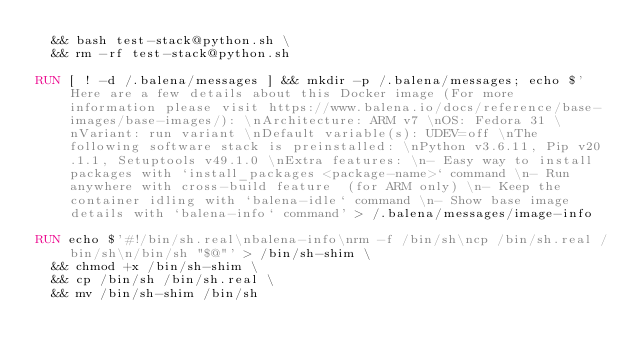<code> <loc_0><loc_0><loc_500><loc_500><_Dockerfile_>  && bash test-stack@python.sh \
  && rm -rf test-stack@python.sh 

RUN [ ! -d /.balena/messages ] && mkdir -p /.balena/messages; echo $'Here are a few details about this Docker image (For more information please visit https://www.balena.io/docs/reference/base-images/base-images/): \nArchitecture: ARM v7 \nOS: Fedora 31 \nVariant: run variant \nDefault variable(s): UDEV=off \nThe following software stack is preinstalled: \nPython v3.6.11, Pip v20.1.1, Setuptools v49.1.0 \nExtra features: \n- Easy way to install packages with `install_packages <package-name>` command \n- Run anywhere with cross-build feature  (for ARM only) \n- Keep the container idling with `balena-idle` command \n- Show base image details with `balena-info` command' > /.balena/messages/image-info

RUN echo $'#!/bin/sh.real\nbalena-info\nrm -f /bin/sh\ncp /bin/sh.real /bin/sh\n/bin/sh "$@"' > /bin/sh-shim \
	&& chmod +x /bin/sh-shim \
	&& cp /bin/sh /bin/sh.real \
	&& mv /bin/sh-shim /bin/sh</code> 